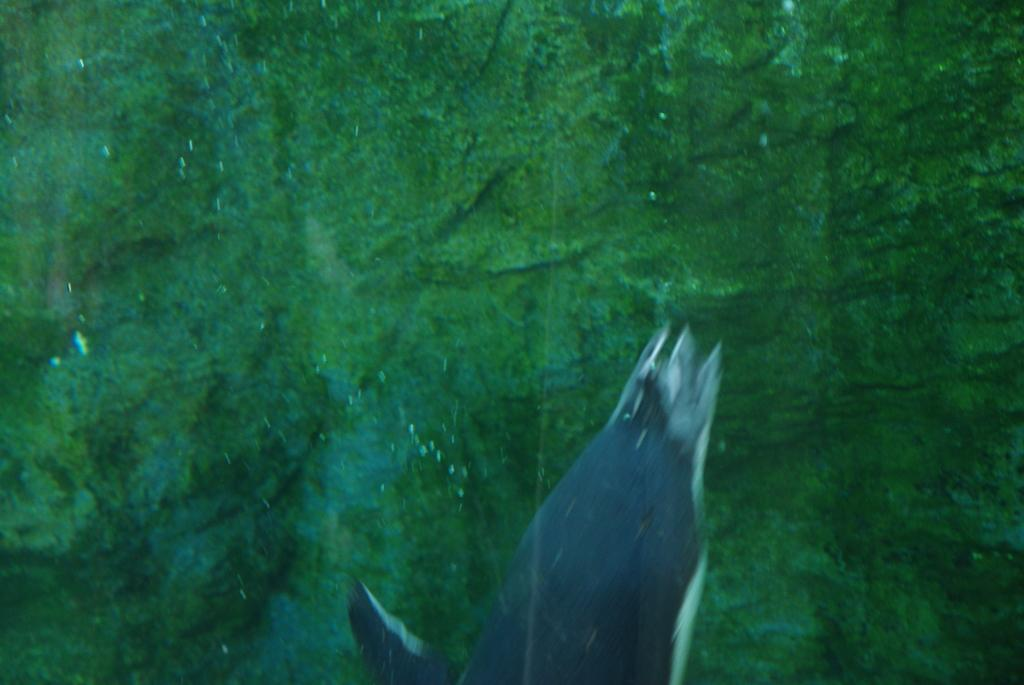What type of animal can be seen in the image? There is an aquatic animal in the image. What color is the floor below the animal? The floor below the animal is in green color. Where is the parcel placed in the image? There is no parcel present in the image. What type of comb is being used by the aquatic animal in the image? The aquatic animal does not use a comb in the image, as it is not a mammal and does not have hair. 